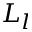<formula> <loc_0><loc_0><loc_500><loc_500>L _ { l }</formula> 